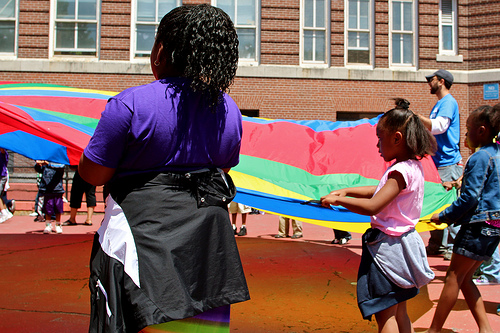<image>
Is there a girl to the left of the girl? Yes. From this viewpoint, the girl is positioned to the left side relative to the girl. Is there a flag in front of the building? Yes. The flag is positioned in front of the building, appearing closer to the camera viewpoint. 